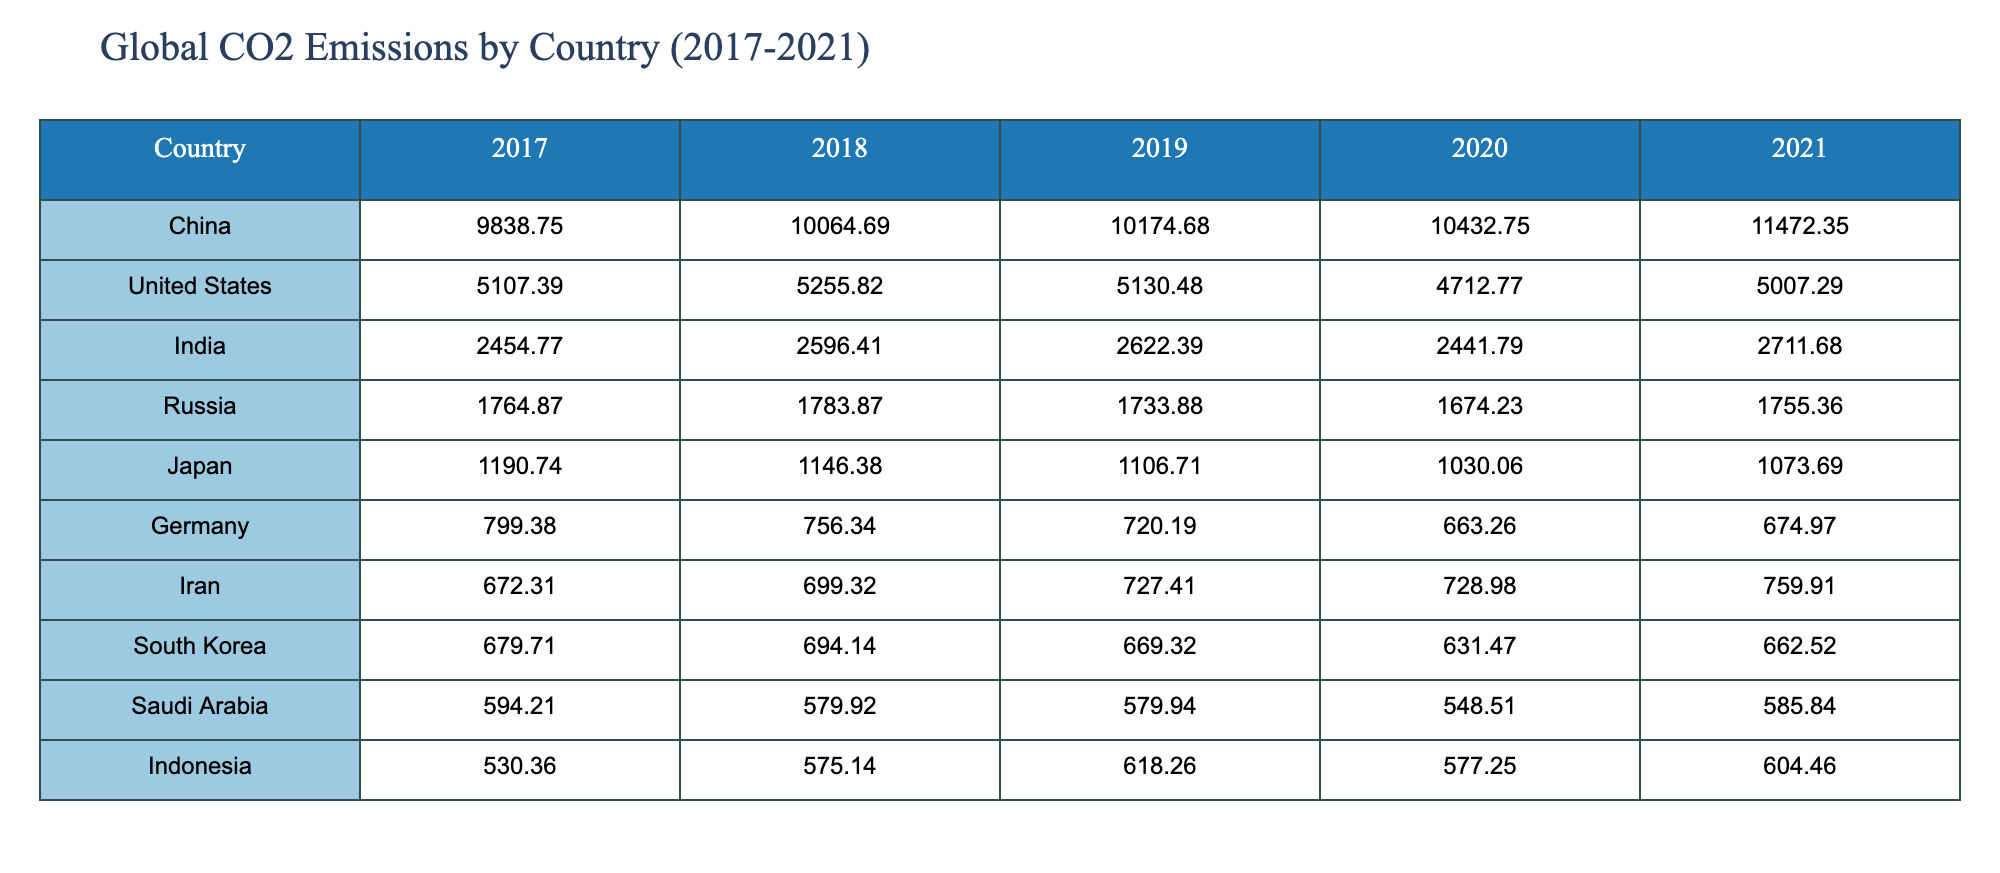What was the CO2 emission of China in 2020? In the table, we look under the "China" row and find the "2020" column, which shows the value 10432.75.
Answer: 10432.75 Which country had the lowest CO2 emissions in 2019? By scanning the table for the "2019" column, we can identify the countries and their emissions. The lowest value is for Germany, which is 720.19.
Answer: Germany What is the total CO2 emissions of India from 2017 to 2021? We need to sum the emissions for India across the years: 2454.77 (2017) + 2596.41 (2018) + 2622.39 (2019) + 2441.79 (2020) + 2711.68 (2021) = 12626.04.
Answer: 12626.04 Did the CO2 emissions of the United States increase from 2019 to 2021? Comparing the emissions in 2019 (5130.48) and 2021 (5007.29), we see that the value decreased. Therefore, the emissions did not increase, indicating a drop.
Answer: No Which country experienced the largest increase in CO2 emissions from 2020 to 2021? We check the emissions values for each country in those two years. The differences are: China (11472.35 - 10432.75 = 1039.60), India (2711.68 - 2441.79 = 269.89), and others. The largest increase is for China, which rose by 1039.60.
Answer: China 